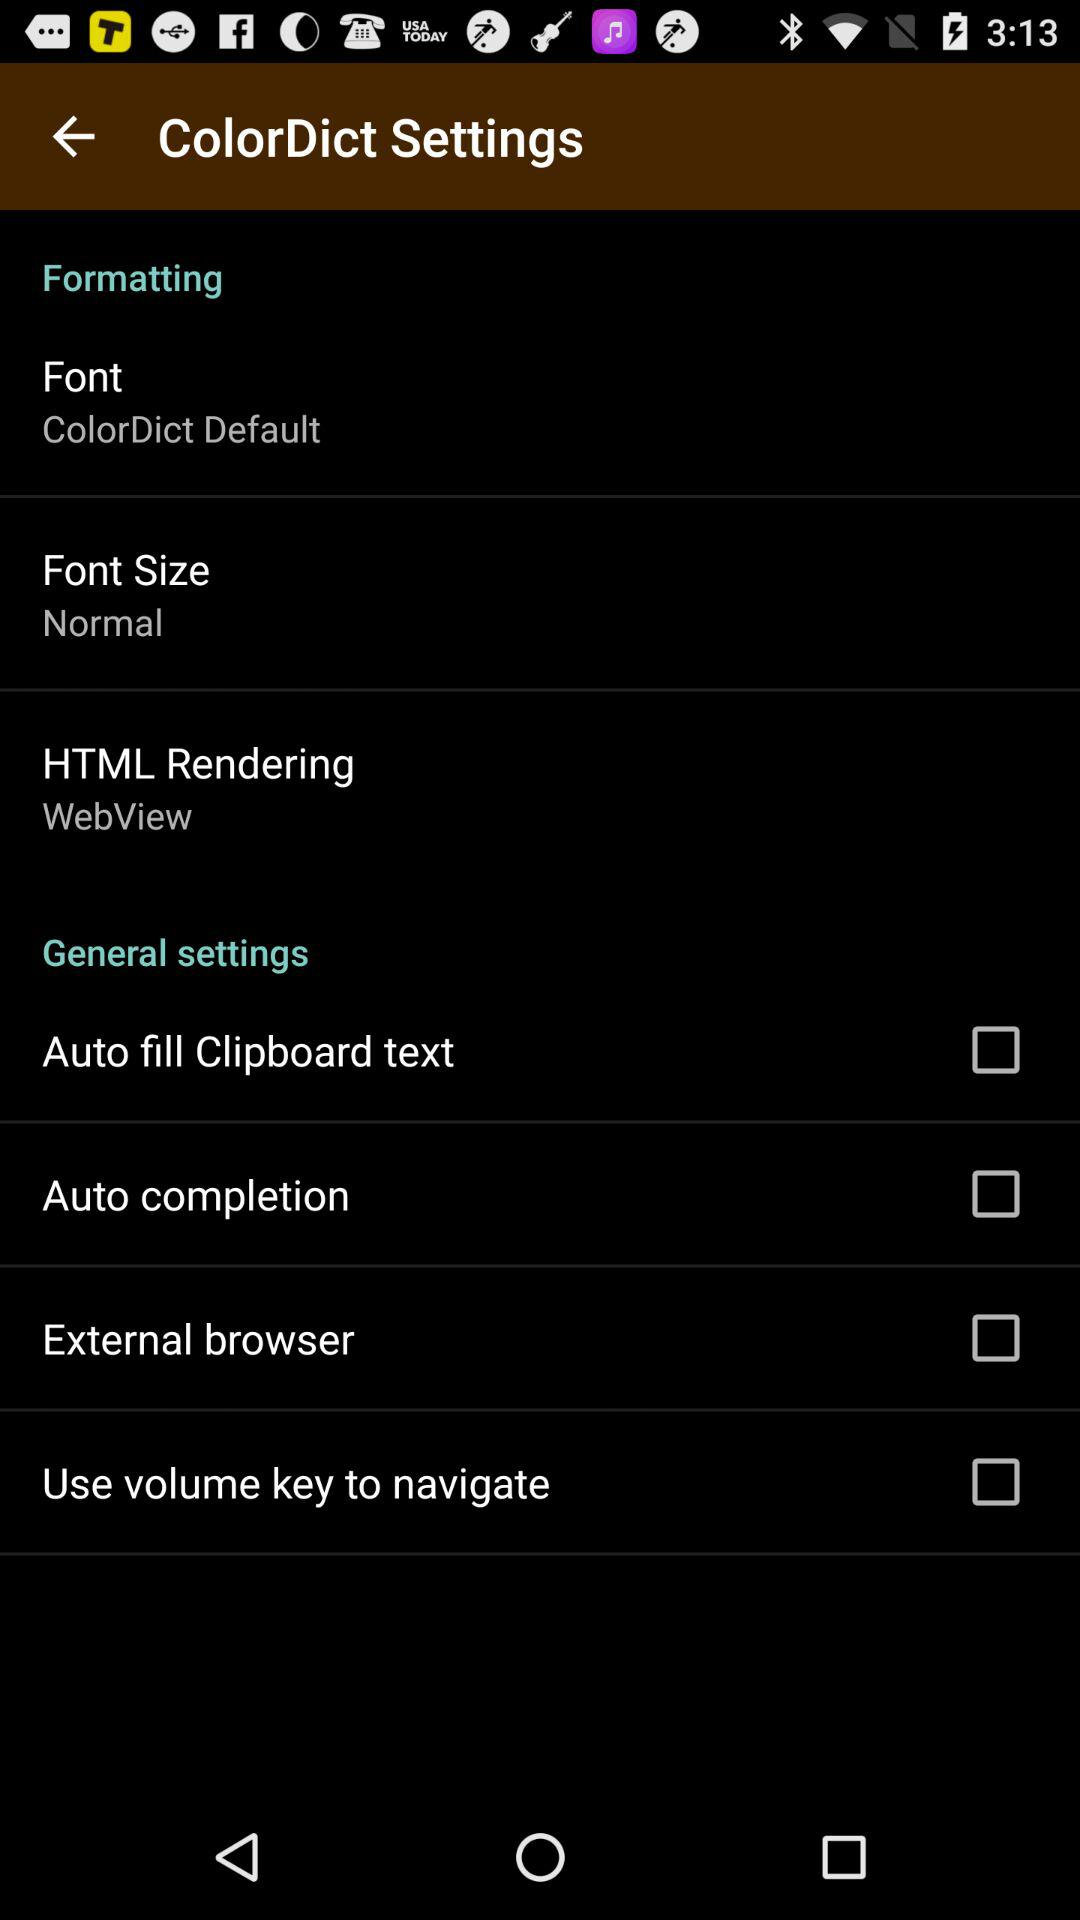How many items have a checkbox in this settings menu?
Answer the question using a single word or phrase. 4 